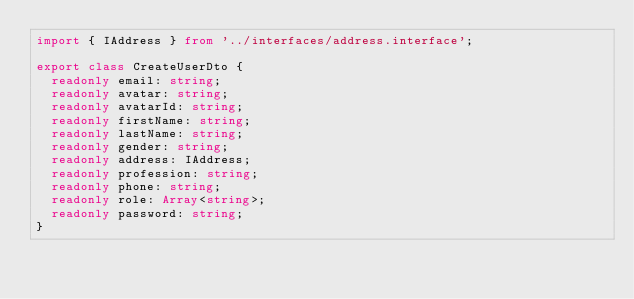<code> <loc_0><loc_0><loc_500><loc_500><_TypeScript_>import { IAddress } from '../interfaces/address.interface';

export class CreateUserDto {
  readonly email: string;
  readonly avatar: string;
  readonly avatarId: string;
  readonly firstName: string;
  readonly lastName: string;
  readonly gender: string;
  readonly address: IAddress;
  readonly profession: string;
  readonly phone: string;
  readonly role: Array<string>;
  readonly password: string;
}
</code> 